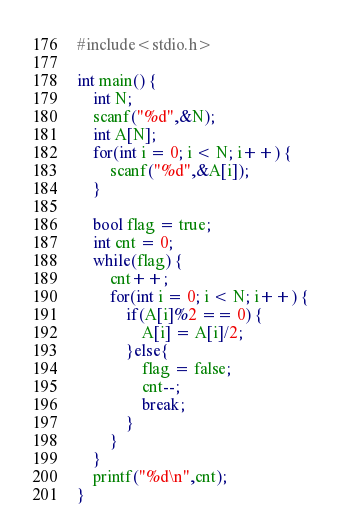<code> <loc_0><loc_0><loc_500><loc_500><_C++_>#include<stdio.h>

int main() {
    int N;
    scanf("%d",&N);
    int A[N];
    for(int i = 0; i < N; i++) {
        scanf("%d",&A[i]);
    }

    bool flag = true;
    int cnt = 0;
    while(flag) {
        cnt++;
        for(int i = 0; i < N; i++) {
            if(A[i]%2 == 0) {
                A[i] = A[i]/2;
            }else{
                flag = false;
                cnt--;
                break;
            }
        }
    }
    printf("%d\n",cnt);
}
</code> 